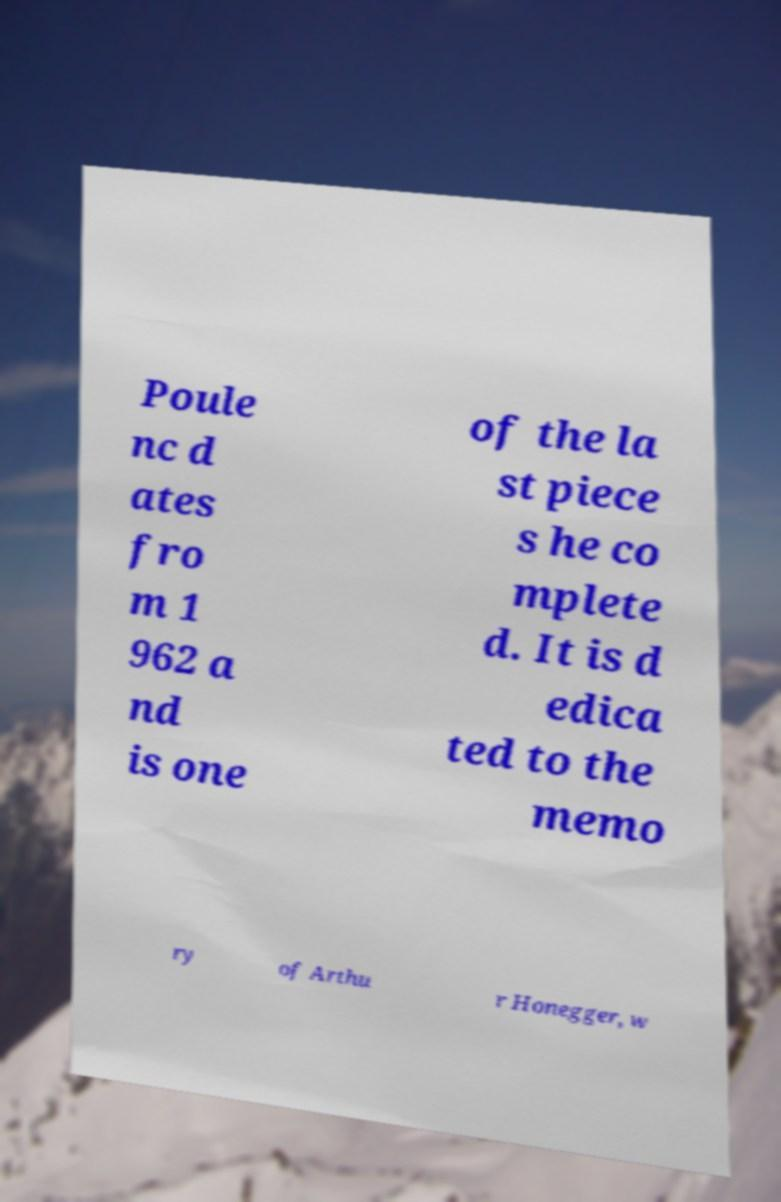There's text embedded in this image that I need extracted. Can you transcribe it verbatim? Poule nc d ates fro m 1 962 a nd is one of the la st piece s he co mplete d. It is d edica ted to the memo ry of Arthu r Honegger, w 